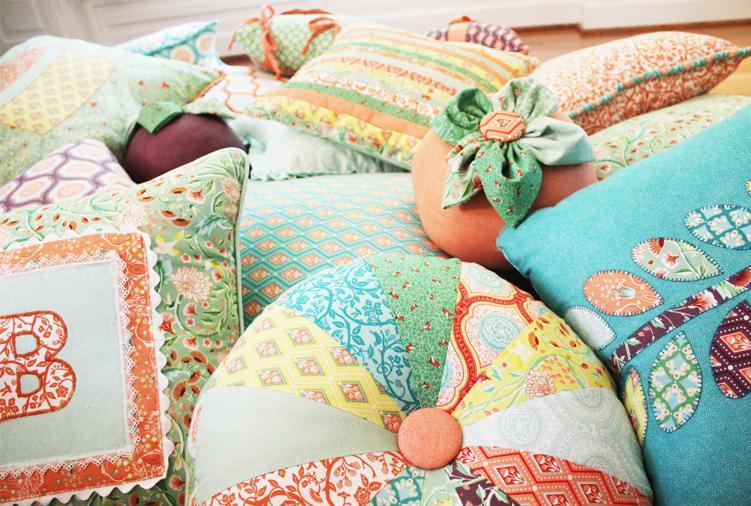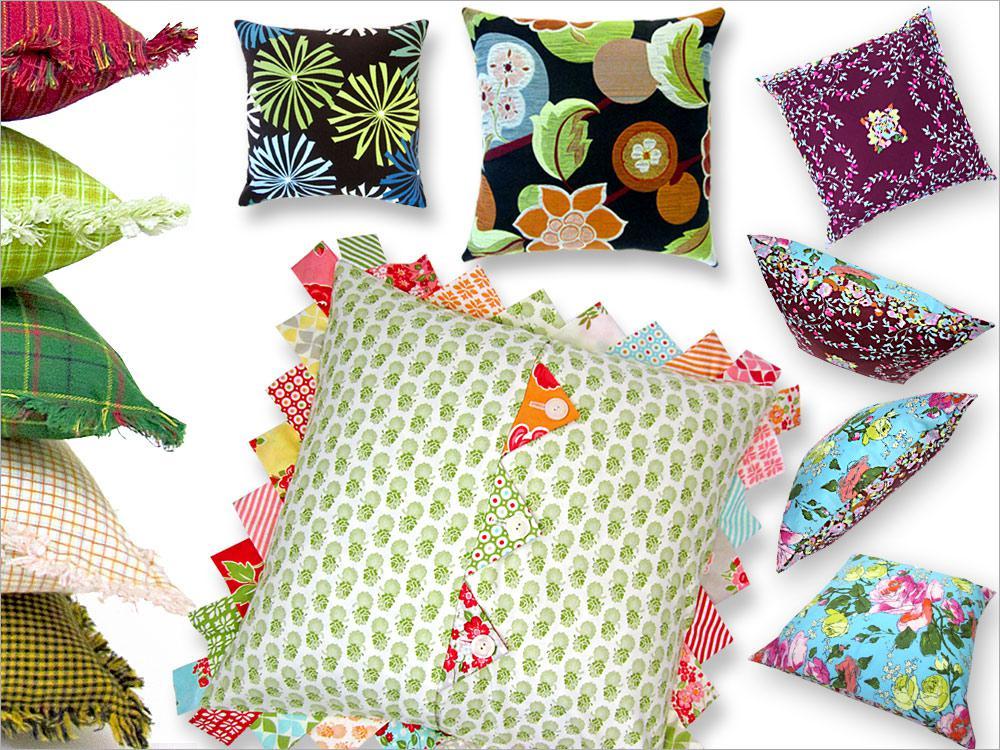The first image is the image on the left, the second image is the image on the right. Considering the images on both sides, is "Some of the pillows are round in shape." valid? Answer yes or no. Yes. The first image is the image on the left, the second image is the image on the right. Evaluate the accuracy of this statement regarding the images: "The pillow display in one image includes a round wheel shape with a button center.". Is it true? Answer yes or no. Yes. 